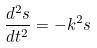Convert formula to latex. <formula><loc_0><loc_0><loc_500><loc_500>\frac { d ^ { 2 } s } { d t ^ { 2 } } = - k ^ { 2 } s</formula> 